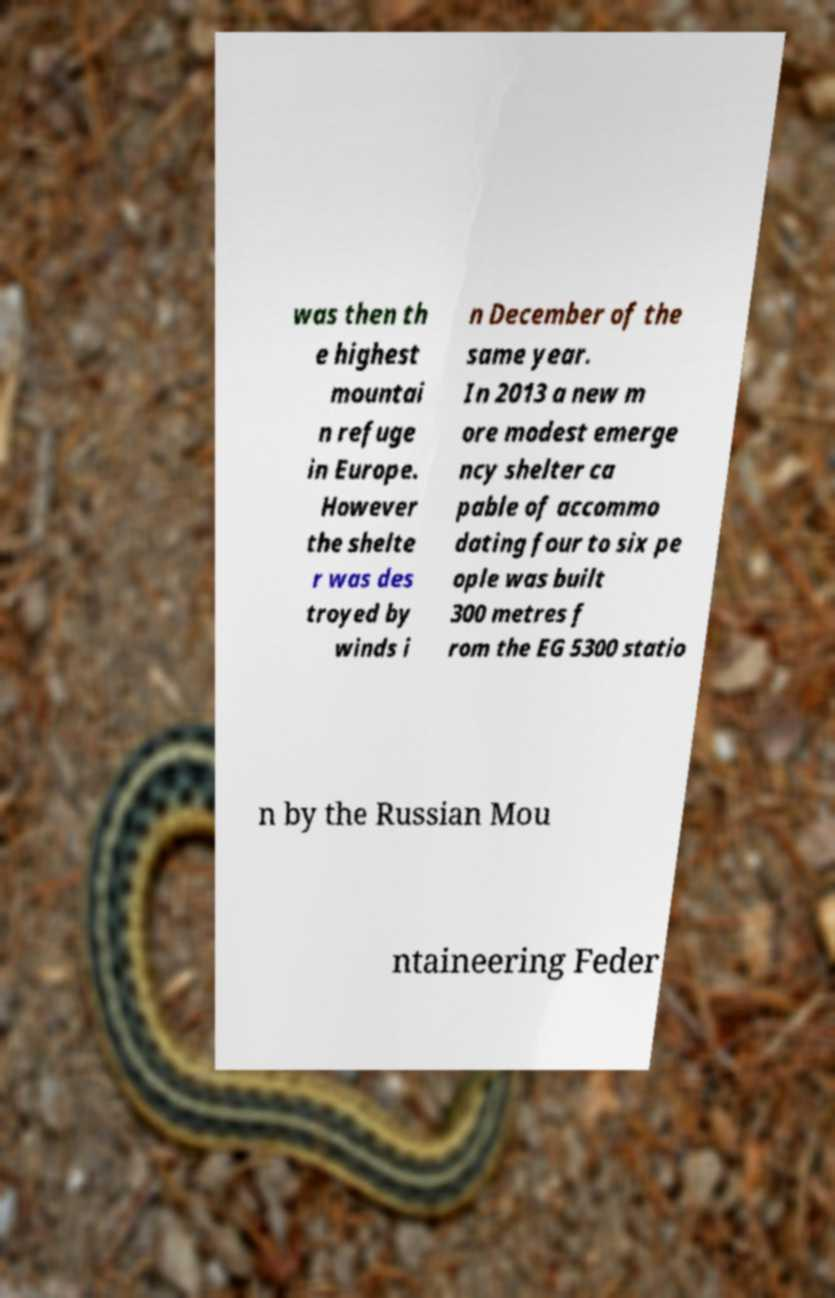For documentation purposes, I need the text within this image transcribed. Could you provide that? was then th e highest mountai n refuge in Europe. However the shelte r was des troyed by winds i n December of the same year. In 2013 a new m ore modest emerge ncy shelter ca pable of accommo dating four to six pe ople was built 300 metres f rom the EG 5300 statio n by the Russian Mou ntaineering Feder 